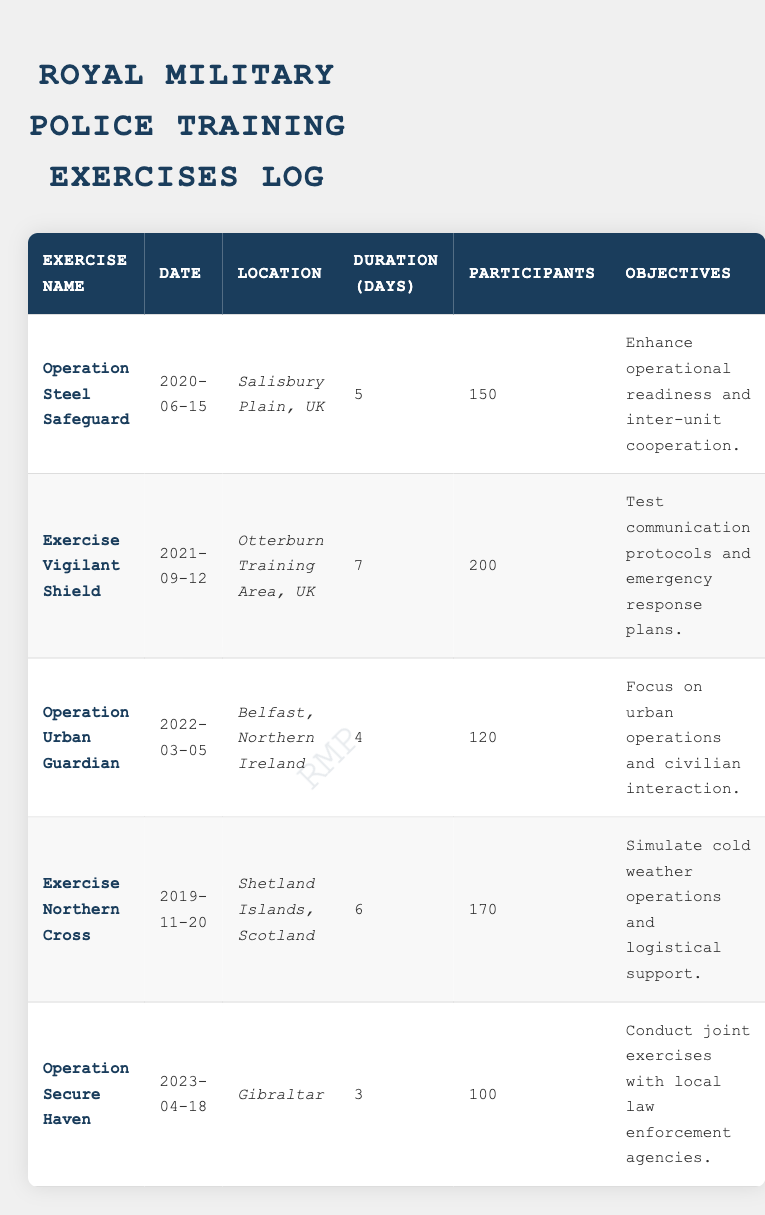What is the location of the Exercise Vigilant Shield? The table lists the location for each exercise. For Exercise Vigilant Shield, the corresponding location is stated as Otterburn Training Area, UK.
Answer: Otterburn Training Area, UK How many participants were involved in the Operation Urban Guardian? In the table, the number of participants for each exercise is provided. For Operation Urban Guardian, the number of participants is given as 120.
Answer: 120 What is the total duration of all exercises conducted? To find the total duration, add the duration of each exercise: 5 + 7 + 4 + 6 + 3 = 25 days.
Answer: 25 days Was the Exercise Northern Cross conducted before the year 2020? The date for Exercise Northern Cross is noted as 2019-11-20. Since this date is before 2020, the answer is true.
Answer: Yes Which exercise had the least number of participants? Checking the number of participants for each exercise: 150 (Steel Safeguard), 200 (Vigilant Shield), 120 (Urban Guardian), 170 (Northern Cross), and 100 (Secure Haven). The least number is 100 from Operation Secure Haven.
Answer: Operation Secure Haven Which two exercises have a duration of more than five days? The exercises with durations over five days are Exercise Vigilant Shield (7 days) and Exercise Northern Cross (6 days).
Answer: Exercise Vigilant Shield and Exercise Northern Cross What is the objective of Operation Secure Haven? According to the table, the objective for each exercise is specified. For Operation Secure Haven, the objective is to conduct joint exercises with local law enforcement agencies.
Answer: Conduct joint exercises with local law enforcement agencies What was the average number of participants across all exercises? To calculate the average number of participants, sum the participants: 150 + 200 + 120 + 170 + 100 = 840. Then, divide by the number of exercises (5): 840 / 5 = 168.
Answer: 168 How many exercises took place in Northern Ireland? Looking at the table, there is one exercise listed in Northern Ireland, which is Operation Urban Guardian.
Answer: 1 